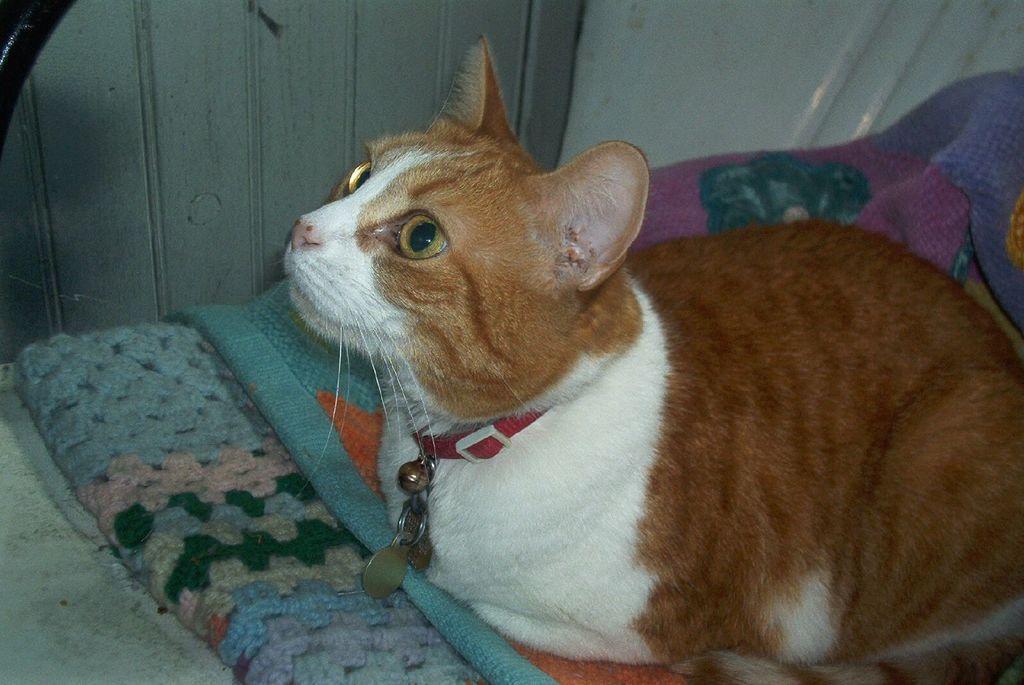Describe this image in one or two sentences. In the image there is a cat which is in white and brown color is sitting on the clothes. Around its neck there is a belt with few lockets. In the background there is a wall. 